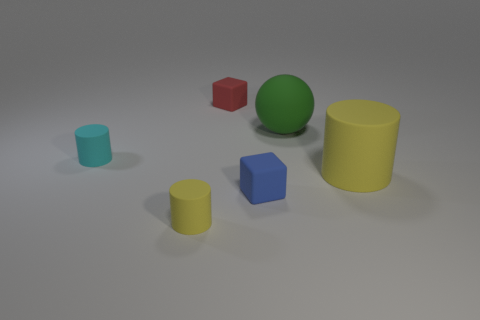How many rubber cylinders are both on the right side of the small yellow object and on the left side of the large yellow matte cylinder? There appear to be no rubber cylinders situated on the right side of the small yellow object and on the left side of the large yellow matte cylinder. All objects are distinctly separate and none fit the criteria of being rubber cylinders between the mentioned objects. 